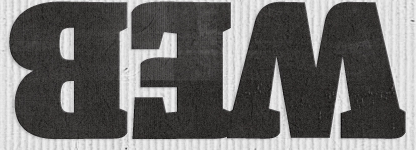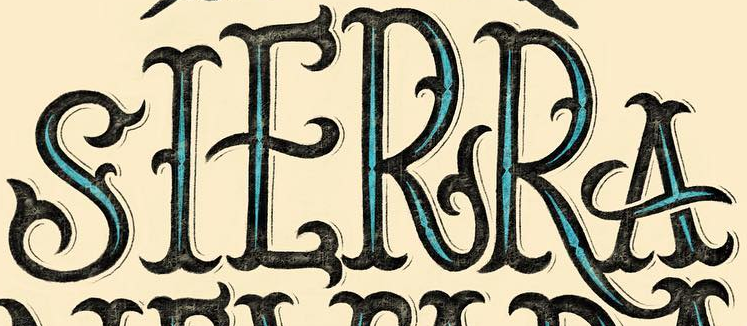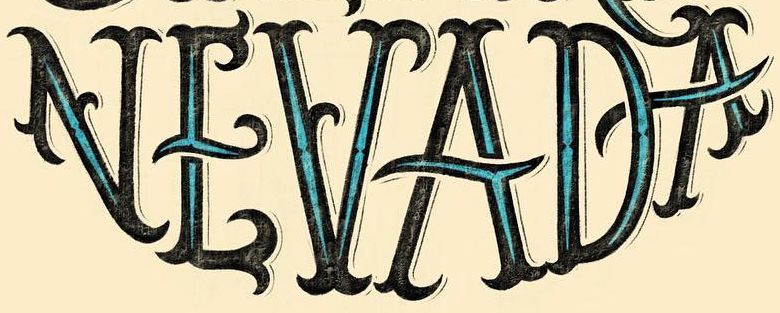Read the text from these images in sequence, separated by a semicolon. WEB; SIERRA; NEVADA 